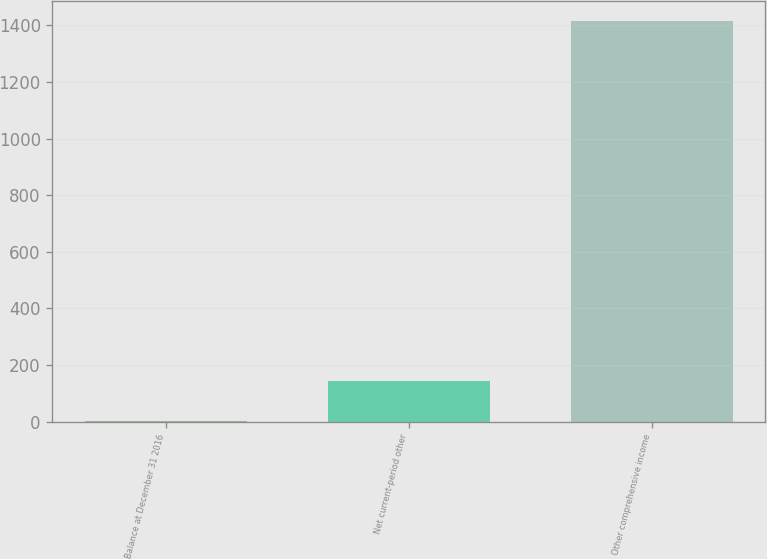<chart> <loc_0><loc_0><loc_500><loc_500><bar_chart><fcel>Balance at December 31 2016<fcel>Net current-period other<fcel>Other comprehensive income<nl><fcel>2<fcel>143.2<fcel>1414<nl></chart> 